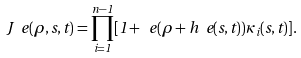<formula> <loc_0><loc_0><loc_500><loc_500>J ^ { \ } e ( \rho , s , t ) = \prod _ { i = 1 } ^ { n - 1 } [ 1 + \ e ( \rho + h ^ { \ } e ( s , t ) ) \kappa _ { i } ( s , t ) ] .</formula> 